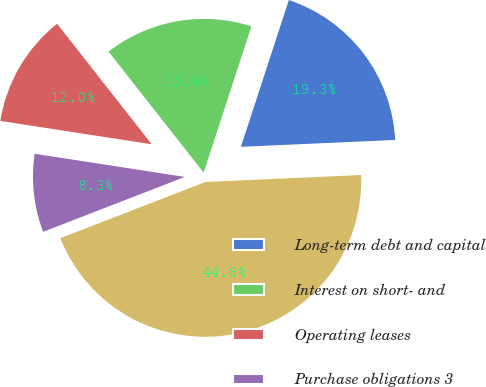Convert chart to OTSL. <chart><loc_0><loc_0><loc_500><loc_500><pie_chart><fcel>Long-term debt and capital<fcel>Interest on short- and<fcel>Operating leases<fcel>Purchase obligations 3<fcel>Contractual obligations 4<nl><fcel>19.27%<fcel>15.62%<fcel>11.97%<fcel>8.32%<fcel>44.83%<nl></chart> 